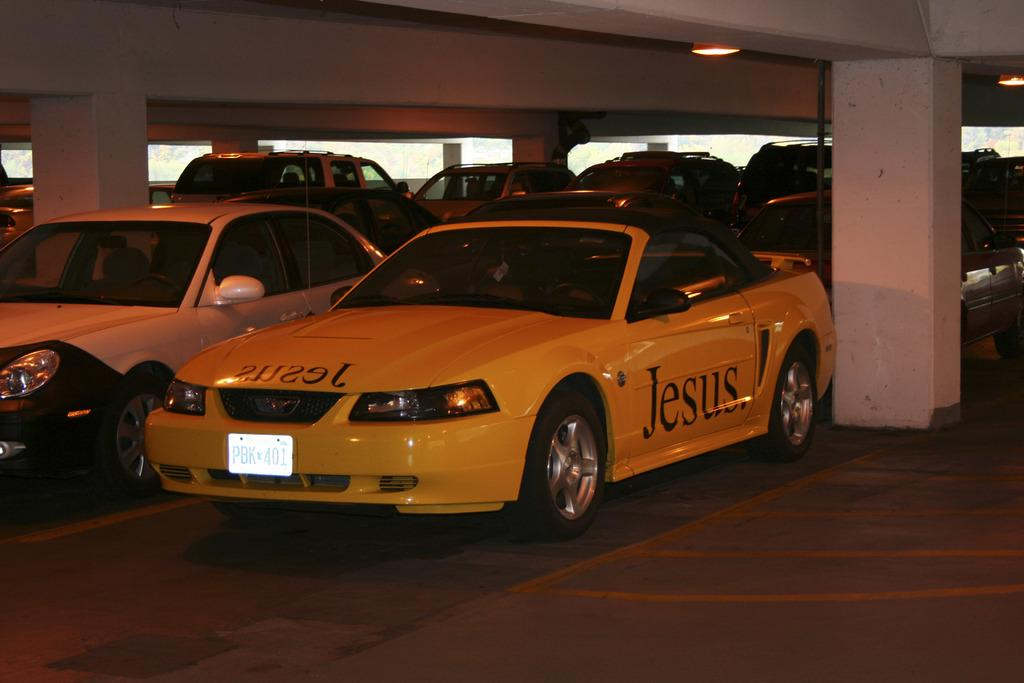What type of area is depicted in the image? The image shows a parking area. Is the parking area connected to any specific location? Yes, the parking area is associated with a building. How many cars can be seen in the parking area? There are many cars parked in the parking area. What type of protest is taking place in the parking area? There is no protest present in the image; it shows a parking area with many cars parked. How does the number of cars in the parking area compare to the number of clovers in the image? There are no clovers present in the image, so it is not possible to make a comparison. 